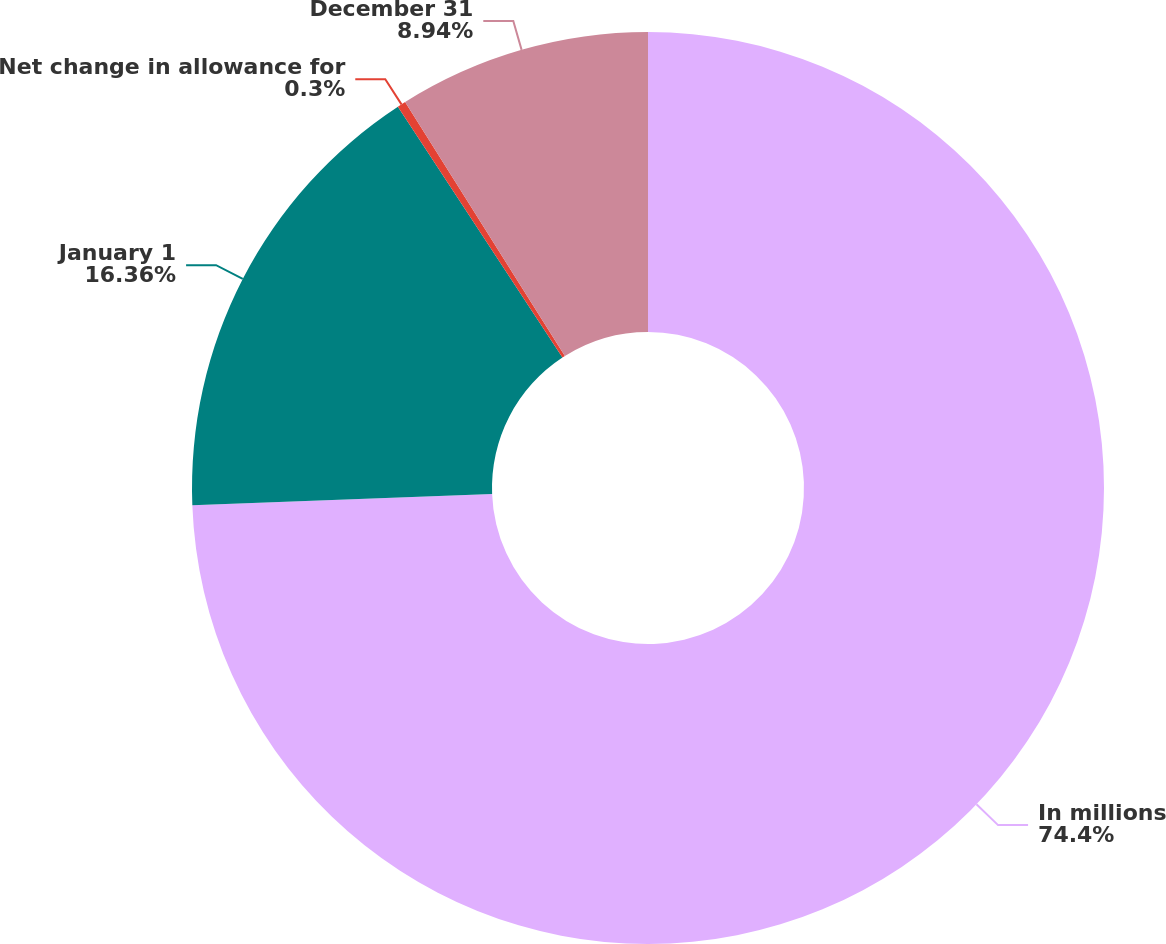Convert chart to OTSL. <chart><loc_0><loc_0><loc_500><loc_500><pie_chart><fcel>In millions<fcel>January 1<fcel>Net change in allowance for<fcel>December 31<nl><fcel>74.4%<fcel>16.36%<fcel>0.3%<fcel>8.94%<nl></chart> 